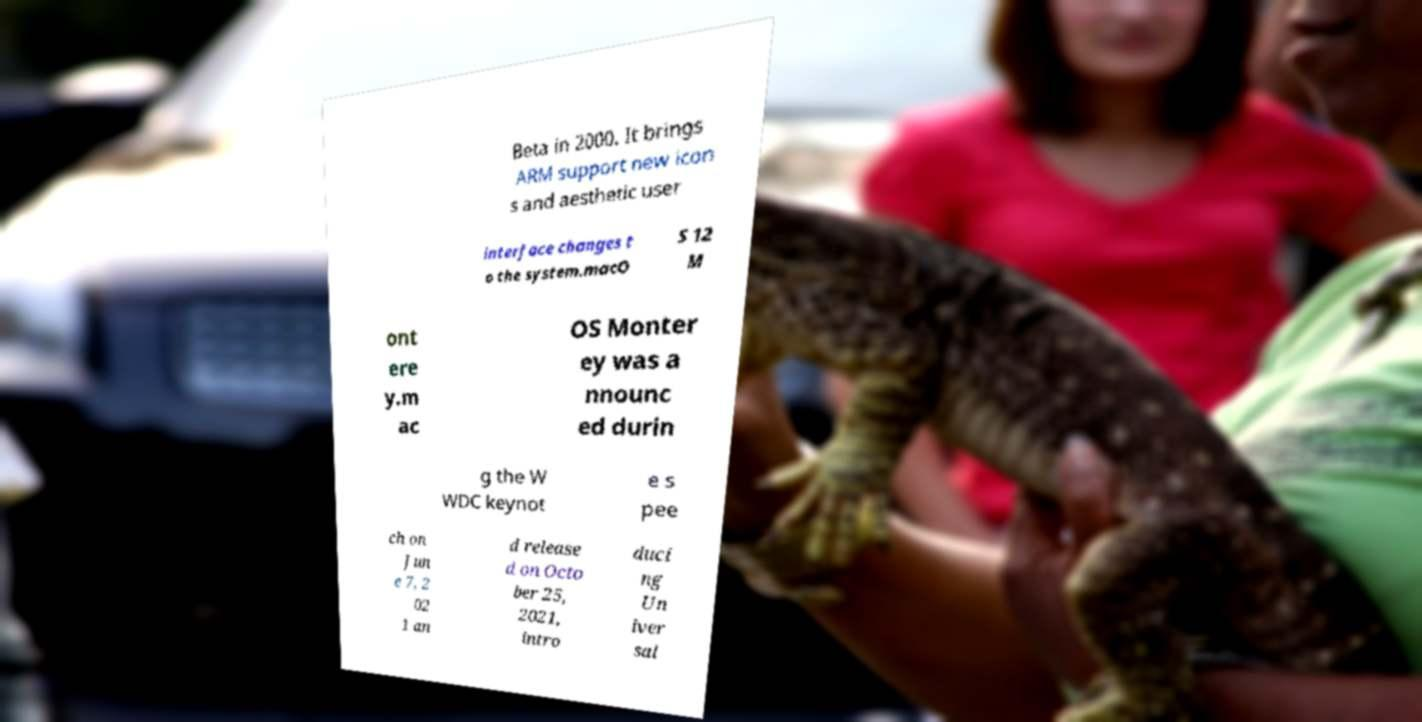What messages or text are displayed in this image? I need them in a readable, typed format. Beta in 2000. It brings ARM support new icon s and aesthetic user interface changes t o the system.macO S 12 M ont ere y.m ac OS Monter ey was a nnounc ed durin g the W WDC keynot e s pee ch on Jun e 7, 2 02 1 an d release d on Octo ber 25, 2021, intro duci ng Un iver sal 